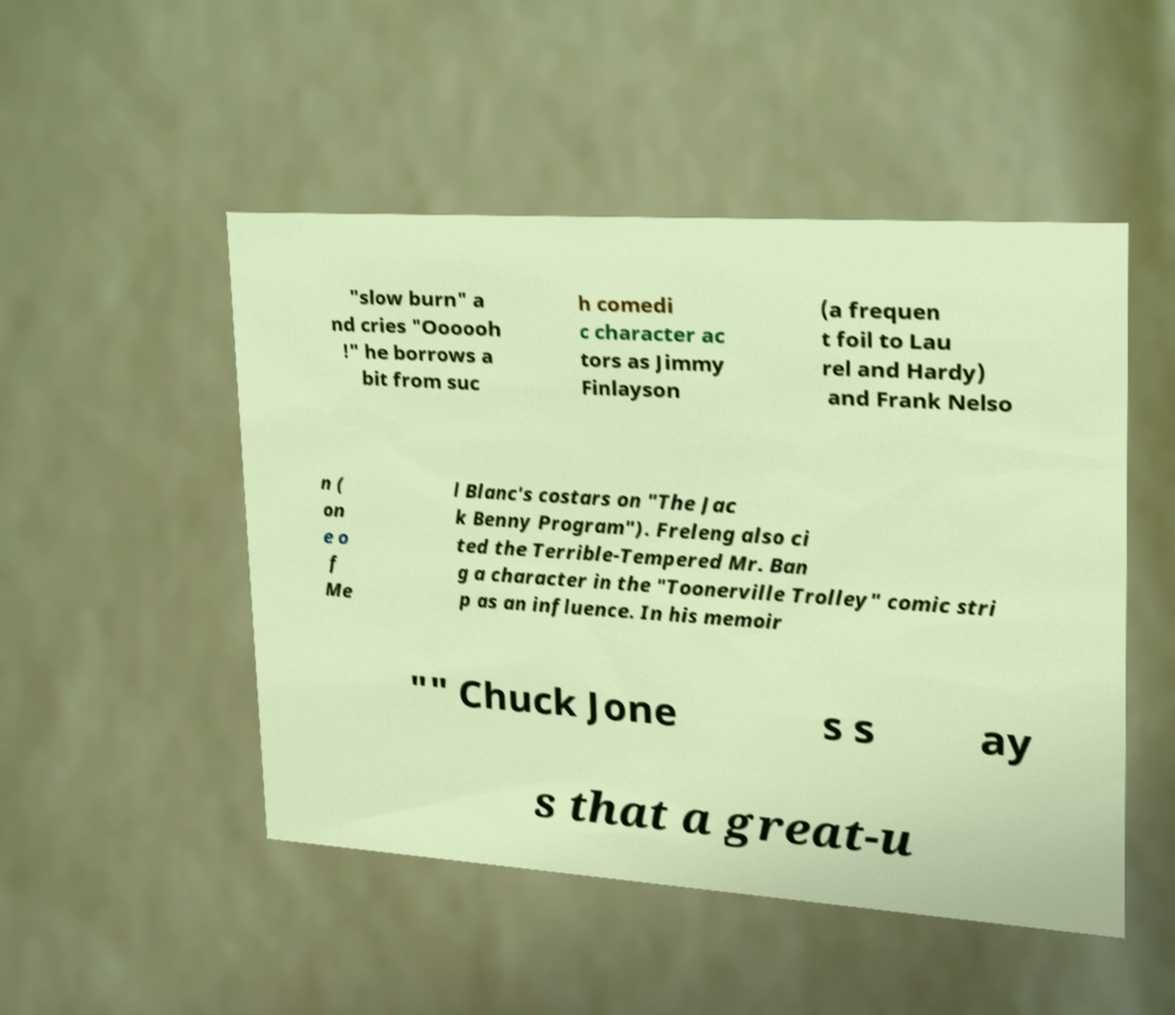Please identify and transcribe the text found in this image. "slow burn" a nd cries "Oooooh !" he borrows a bit from suc h comedi c character ac tors as Jimmy Finlayson (a frequen t foil to Lau rel and Hardy) and Frank Nelso n ( on e o f Me l Blanc's costars on "The Jac k Benny Program"). Freleng also ci ted the Terrible-Tempered Mr. Ban g a character in the "Toonerville Trolley" comic stri p as an influence. In his memoir "" Chuck Jone s s ay s that a great-u 